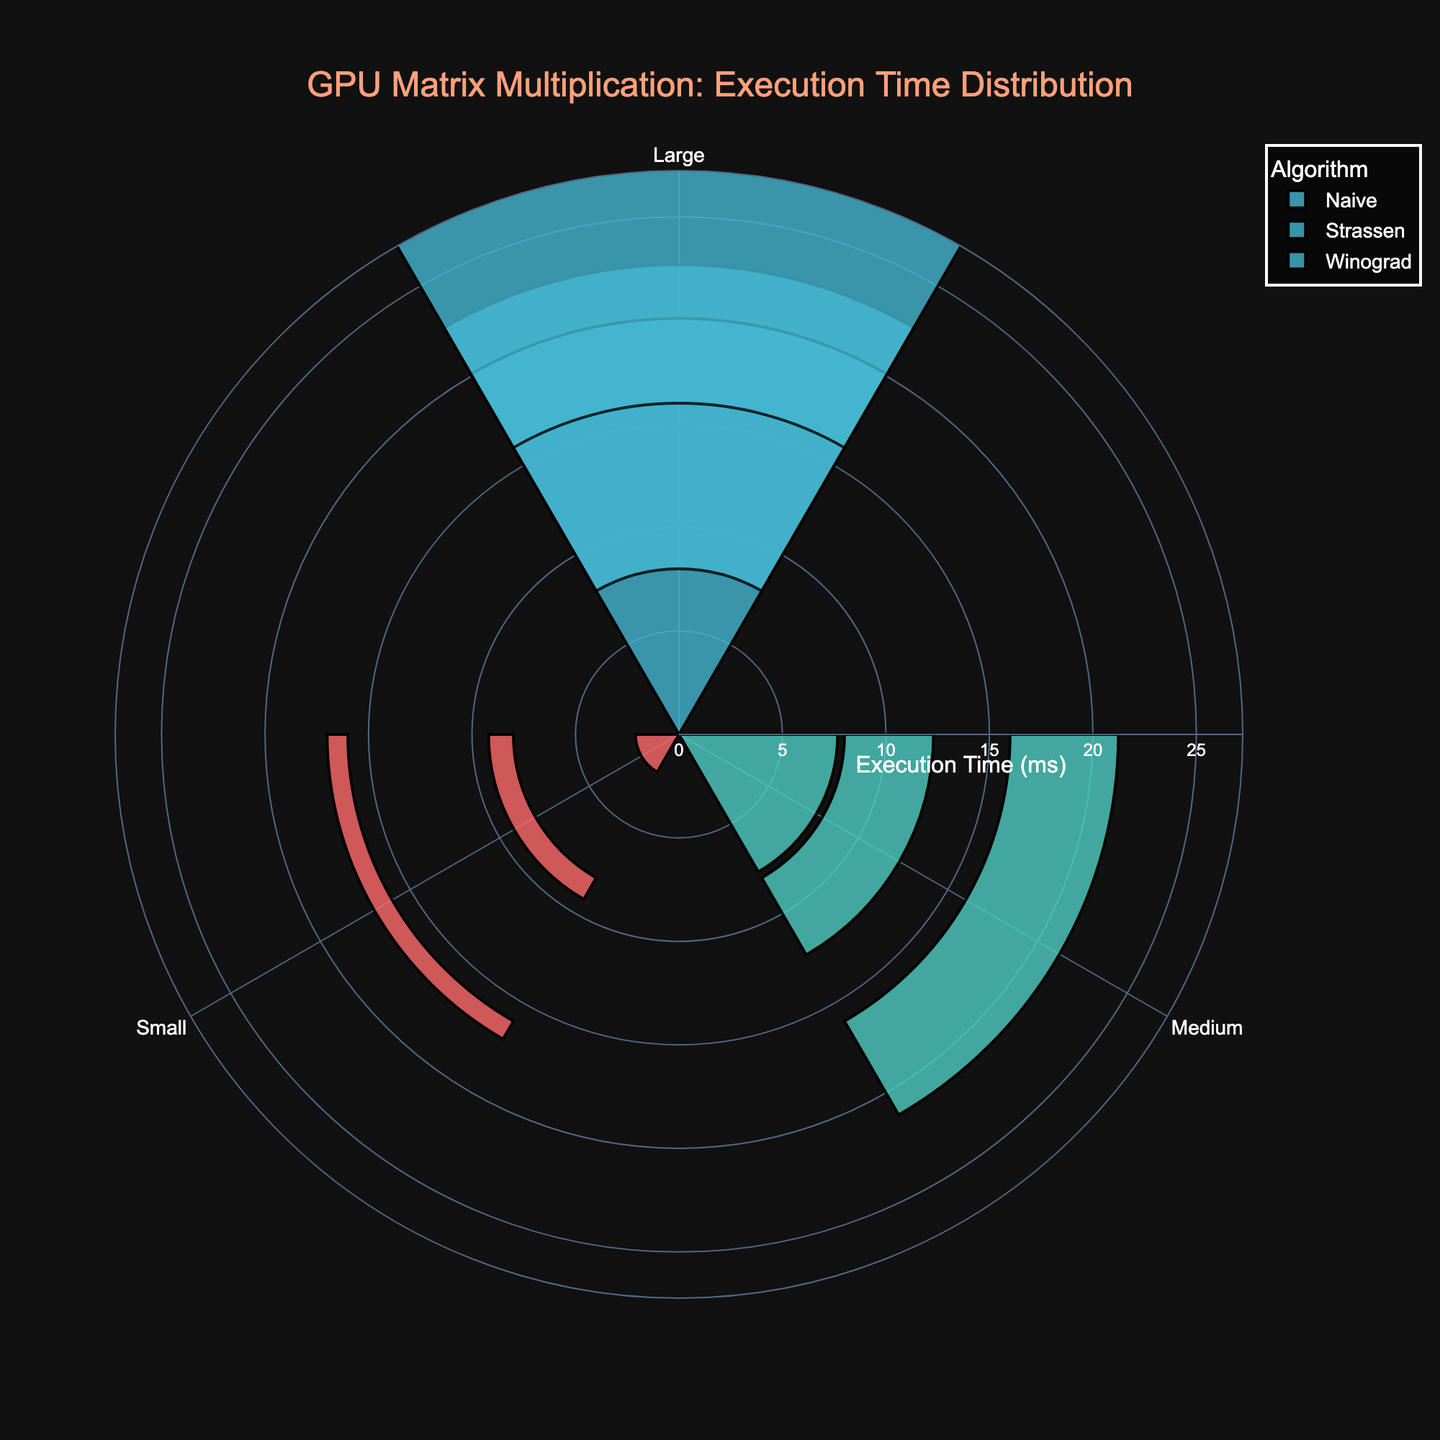What is the title of the rose chart? The title is usually located at the top of the figure. In this figure, it is in a prominent position with the text color '#FFA07A', making it visually distinctive. The text reads "GPU Matrix Multiplication: Execution Time Distribution".
Answer: GPU Matrix Multiplication: Execution Time Distribution What are the matrix size categories used in the figure? The matrix size categories are clearly indicated at the angular axis of the rose chart. These categories are distinct colors, which help in differentiating between them. The categories are 'Small', 'Medium', and 'Large'.
Answer: Small, Medium, Large Which algorithm has the lowest execution time for small matrices? By observing the radial distance for each algorithm's bar for the 'Small' matrix size, the algorithm with the smallest radial distance represents the lowest execution time. The algorithm 'Winograd' has the lowest execution time in this case.
Answer: Winograd What is the average execution time of the Strassen algorithm for large matrices? The average execution time is displayed as a bar's radial length. We can look at the bar corresponding to the Strassen algorithm and the 'Large' matrix size. This bar's length represents the average execution time, indicated as approximately '12.1 ms'.
Answer: 12.1 ms Which algorithm shows the greatest variance in execution time between small and large matrices? To determine variance, compare the bar lengths for each algorithm between the 'Small' and 'Large' categories. Strassen has a much larger difference (from around 1.2 ms to 12.1 ms), whereas Winograd ranges from 1.0 ms to approximately 15.3 ms, showing the greatest range of variance.
Answer: Winograd By how much does the execution time for the Naive algorithm increase when moving from medium to large matrices? First find the Naive algorithm's execution times for 'Medium' (around 7.7 ms) and 'Large' (approximately 22.7 ms) matrices. The difference is calculated as 22.7 - 7.7 = 15 ms.
Answer: 15 ms Which matrix size category consistently shows the highest average execution times across the algorithms? By analyzing the average execution times for each algorithm, 'Large' matrices consistently have the highest values compared to 'Small' and 'Medium' categories. The radial distances for 'Large' are the longest for all algorithms.
Answer: Large How does the average execution time for the Naive algorithm on medium matrices compare to the time for the Strassen algorithm on large matrices? Compare the bars: the Naive algorithm's average time for 'Medium' matrices is around 7.7 ms, while for the Strassen on 'Large', it is 12.1 ms. Clearly, the Strassen algorithm on 'Large' matrices has a higher execution time.
Answer: The Strassen algorithm on large matrices has a higher execution time Describe how the angular axis is utilized in the rose chart. The angular axis represents the different matrix size categories ('Small', 'Medium', 'Large'), which are organized circularly around the center. Each segment corresponds to a different matrix size category, where bars are plotted radially to indicate execution times.
Answer: Different matrix sizes are represented by angular segments 